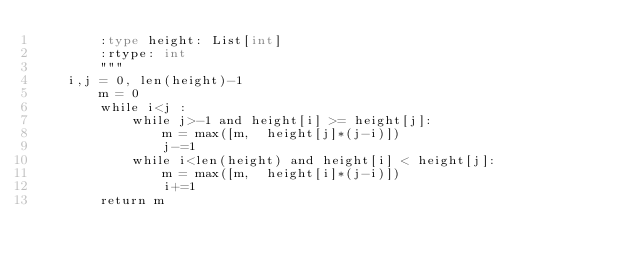Convert code to text. <code><loc_0><loc_0><loc_500><loc_500><_Python_>        :type height: List[int]
        :rtype: int
        """
	i,j = 0, len(height)-1
        m = 0
        while i<j :
            while j>-1 and height[i] >= height[j]:
                m = max([m,  height[j]*(j-i)])
                j-=1
            while i<len(height) and height[i] < height[j]:
                m = max([m,  height[i]*(j-i)])
                i+=1
        return m
</code> 